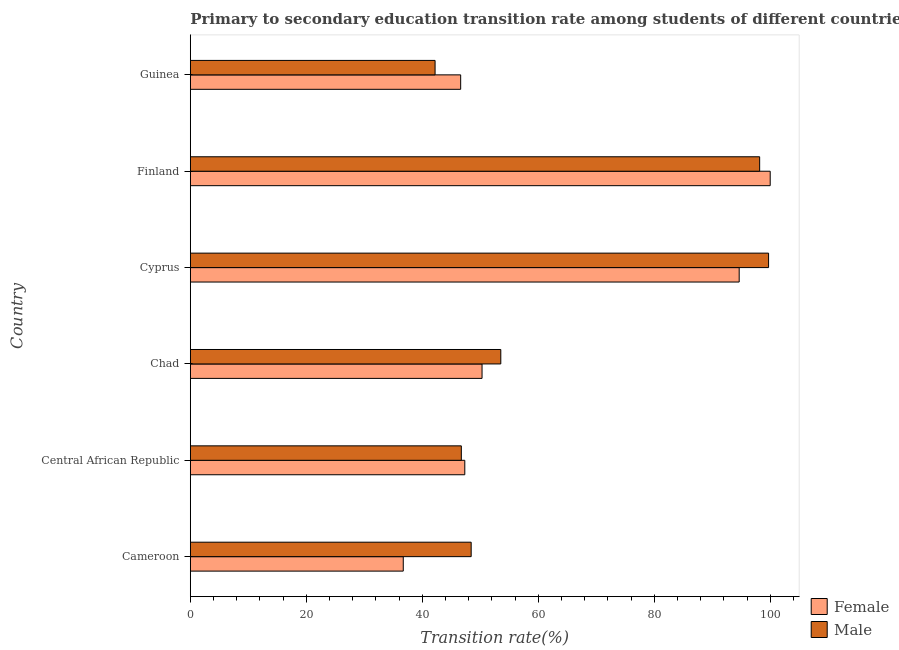Are the number of bars on each tick of the Y-axis equal?
Give a very brief answer. Yes. How many bars are there on the 4th tick from the top?
Offer a terse response. 2. What is the label of the 5th group of bars from the top?
Offer a very short reply. Central African Republic. What is the transition rate among female students in Cameroon?
Make the answer very short. 36.73. Across all countries, what is the maximum transition rate among female students?
Make the answer very short. 100. Across all countries, what is the minimum transition rate among female students?
Your response must be concise. 36.73. In which country was the transition rate among male students maximum?
Offer a very short reply. Cyprus. In which country was the transition rate among male students minimum?
Offer a very short reply. Guinea. What is the total transition rate among female students in the graph?
Your response must be concise. 375.65. What is the difference between the transition rate among female students in Cyprus and that in Guinea?
Your answer should be very brief. 48.03. What is the difference between the transition rate among male students in Finland and the transition rate among female students in Cyprus?
Give a very brief answer. 3.53. What is the average transition rate among male students per country?
Your response must be concise. 64.81. What is the difference between the transition rate among male students and transition rate among female students in Finland?
Offer a terse response. -1.82. What is the ratio of the transition rate among male students in Cameroon to that in Guinea?
Make the answer very short. 1.15. Is the difference between the transition rate among male students in Central African Republic and Chad greater than the difference between the transition rate among female students in Central African Republic and Chad?
Offer a terse response. No. What is the difference between the highest and the second highest transition rate among male students?
Ensure brevity in your answer.  1.54. What is the difference between the highest and the lowest transition rate among male students?
Give a very brief answer. 57.51. In how many countries, is the transition rate among female students greater than the average transition rate among female students taken over all countries?
Your answer should be compact. 2. What does the 1st bar from the bottom in Central African Republic represents?
Make the answer very short. Female. Are all the bars in the graph horizontal?
Provide a short and direct response. Yes. What is the difference between two consecutive major ticks on the X-axis?
Offer a very short reply. 20. Are the values on the major ticks of X-axis written in scientific E-notation?
Your answer should be compact. No. Does the graph contain grids?
Ensure brevity in your answer.  No. How many legend labels are there?
Offer a very short reply. 2. How are the legend labels stacked?
Provide a succinct answer. Vertical. What is the title of the graph?
Provide a succinct answer. Primary to secondary education transition rate among students of different countries. What is the label or title of the X-axis?
Provide a succinct answer. Transition rate(%). What is the Transition rate(%) in Female in Cameroon?
Offer a terse response. 36.73. What is the Transition rate(%) in Male in Cameroon?
Make the answer very short. 48.44. What is the Transition rate(%) of Female in Central African Republic?
Provide a succinct answer. 47.34. What is the Transition rate(%) of Male in Central African Republic?
Provide a short and direct response. 46.74. What is the Transition rate(%) in Female in Chad?
Provide a succinct answer. 50.31. What is the Transition rate(%) of Male in Chad?
Offer a terse response. 53.54. What is the Transition rate(%) of Female in Cyprus?
Your answer should be compact. 94.65. What is the Transition rate(%) in Male in Cyprus?
Provide a succinct answer. 99.72. What is the Transition rate(%) of Male in Finland?
Provide a succinct answer. 98.18. What is the Transition rate(%) of Female in Guinea?
Offer a very short reply. 46.62. What is the Transition rate(%) of Male in Guinea?
Your answer should be compact. 42.21. Across all countries, what is the maximum Transition rate(%) of Female?
Your response must be concise. 100. Across all countries, what is the maximum Transition rate(%) in Male?
Your answer should be compact. 99.72. Across all countries, what is the minimum Transition rate(%) of Female?
Offer a terse response. 36.73. Across all countries, what is the minimum Transition rate(%) in Male?
Keep it short and to the point. 42.21. What is the total Transition rate(%) of Female in the graph?
Keep it short and to the point. 375.65. What is the total Transition rate(%) in Male in the graph?
Provide a succinct answer. 388.83. What is the difference between the Transition rate(%) of Female in Cameroon and that in Central African Republic?
Your response must be concise. -10.61. What is the difference between the Transition rate(%) of Male in Cameroon and that in Central African Republic?
Offer a very short reply. 1.7. What is the difference between the Transition rate(%) of Female in Cameroon and that in Chad?
Make the answer very short. -13.58. What is the difference between the Transition rate(%) in Male in Cameroon and that in Chad?
Offer a very short reply. -5.11. What is the difference between the Transition rate(%) in Female in Cameroon and that in Cyprus?
Provide a short and direct response. -57.93. What is the difference between the Transition rate(%) in Male in Cameroon and that in Cyprus?
Provide a succinct answer. -51.29. What is the difference between the Transition rate(%) in Female in Cameroon and that in Finland?
Your answer should be very brief. -63.27. What is the difference between the Transition rate(%) of Male in Cameroon and that in Finland?
Keep it short and to the point. -49.75. What is the difference between the Transition rate(%) in Female in Cameroon and that in Guinea?
Provide a short and direct response. -9.9. What is the difference between the Transition rate(%) of Male in Cameroon and that in Guinea?
Make the answer very short. 6.22. What is the difference between the Transition rate(%) of Female in Central African Republic and that in Chad?
Keep it short and to the point. -2.97. What is the difference between the Transition rate(%) of Male in Central African Republic and that in Chad?
Your answer should be compact. -6.81. What is the difference between the Transition rate(%) in Female in Central African Republic and that in Cyprus?
Give a very brief answer. -47.32. What is the difference between the Transition rate(%) in Male in Central African Republic and that in Cyprus?
Make the answer very short. -52.98. What is the difference between the Transition rate(%) of Female in Central African Republic and that in Finland?
Provide a short and direct response. -52.66. What is the difference between the Transition rate(%) in Male in Central African Republic and that in Finland?
Keep it short and to the point. -51.44. What is the difference between the Transition rate(%) in Female in Central African Republic and that in Guinea?
Offer a terse response. 0.71. What is the difference between the Transition rate(%) in Male in Central African Republic and that in Guinea?
Provide a short and direct response. 4.53. What is the difference between the Transition rate(%) of Female in Chad and that in Cyprus?
Provide a succinct answer. -44.34. What is the difference between the Transition rate(%) of Male in Chad and that in Cyprus?
Offer a terse response. -46.18. What is the difference between the Transition rate(%) of Female in Chad and that in Finland?
Your answer should be compact. -49.69. What is the difference between the Transition rate(%) of Male in Chad and that in Finland?
Ensure brevity in your answer.  -44.64. What is the difference between the Transition rate(%) of Female in Chad and that in Guinea?
Your answer should be compact. 3.69. What is the difference between the Transition rate(%) in Male in Chad and that in Guinea?
Offer a terse response. 11.33. What is the difference between the Transition rate(%) in Female in Cyprus and that in Finland?
Make the answer very short. -5.35. What is the difference between the Transition rate(%) of Male in Cyprus and that in Finland?
Give a very brief answer. 1.54. What is the difference between the Transition rate(%) of Female in Cyprus and that in Guinea?
Provide a succinct answer. 48.03. What is the difference between the Transition rate(%) in Male in Cyprus and that in Guinea?
Provide a short and direct response. 57.51. What is the difference between the Transition rate(%) in Female in Finland and that in Guinea?
Offer a very short reply. 53.38. What is the difference between the Transition rate(%) in Male in Finland and that in Guinea?
Offer a terse response. 55.97. What is the difference between the Transition rate(%) in Female in Cameroon and the Transition rate(%) in Male in Central African Republic?
Provide a short and direct response. -10.01. What is the difference between the Transition rate(%) in Female in Cameroon and the Transition rate(%) in Male in Chad?
Your response must be concise. -16.82. What is the difference between the Transition rate(%) in Female in Cameroon and the Transition rate(%) in Male in Cyprus?
Give a very brief answer. -63. What is the difference between the Transition rate(%) of Female in Cameroon and the Transition rate(%) of Male in Finland?
Your answer should be compact. -61.46. What is the difference between the Transition rate(%) in Female in Cameroon and the Transition rate(%) in Male in Guinea?
Keep it short and to the point. -5.49. What is the difference between the Transition rate(%) in Female in Central African Republic and the Transition rate(%) in Male in Chad?
Offer a terse response. -6.21. What is the difference between the Transition rate(%) of Female in Central African Republic and the Transition rate(%) of Male in Cyprus?
Your answer should be very brief. -52.39. What is the difference between the Transition rate(%) in Female in Central African Republic and the Transition rate(%) in Male in Finland?
Provide a succinct answer. -50.85. What is the difference between the Transition rate(%) in Female in Central African Republic and the Transition rate(%) in Male in Guinea?
Your answer should be compact. 5.12. What is the difference between the Transition rate(%) in Female in Chad and the Transition rate(%) in Male in Cyprus?
Make the answer very short. -49.41. What is the difference between the Transition rate(%) of Female in Chad and the Transition rate(%) of Male in Finland?
Keep it short and to the point. -47.87. What is the difference between the Transition rate(%) in Female in Chad and the Transition rate(%) in Male in Guinea?
Provide a short and direct response. 8.1. What is the difference between the Transition rate(%) of Female in Cyprus and the Transition rate(%) of Male in Finland?
Your answer should be compact. -3.53. What is the difference between the Transition rate(%) in Female in Cyprus and the Transition rate(%) in Male in Guinea?
Offer a terse response. 52.44. What is the difference between the Transition rate(%) of Female in Finland and the Transition rate(%) of Male in Guinea?
Keep it short and to the point. 57.79. What is the average Transition rate(%) of Female per country?
Your answer should be very brief. 62.61. What is the average Transition rate(%) in Male per country?
Your answer should be very brief. 64.81. What is the difference between the Transition rate(%) of Female and Transition rate(%) of Male in Cameroon?
Your answer should be compact. -11.71. What is the difference between the Transition rate(%) in Female and Transition rate(%) in Male in Central African Republic?
Keep it short and to the point. 0.6. What is the difference between the Transition rate(%) in Female and Transition rate(%) in Male in Chad?
Provide a short and direct response. -3.23. What is the difference between the Transition rate(%) in Female and Transition rate(%) in Male in Cyprus?
Offer a very short reply. -5.07. What is the difference between the Transition rate(%) of Female and Transition rate(%) of Male in Finland?
Offer a terse response. 1.82. What is the difference between the Transition rate(%) in Female and Transition rate(%) in Male in Guinea?
Your answer should be compact. 4.41. What is the ratio of the Transition rate(%) in Female in Cameroon to that in Central African Republic?
Keep it short and to the point. 0.78. What is the ratio of the Transition rate(%) of Male in Cameroon to that in Central African Republic?
Offer a terse response. 1.04. What is the ratio of the Transition rate(%) of Female in Cameroon to that in Chad?
Offer a very short reply. 0.73. What is the ratio of the Transition rate(%) of Male in Cameroon to that in Chad?
Keep it short and to the point. 0.9. What is the ratio of the Transition rate(%) in Female in Cameroon to that in Cyprus?
Your answer should be very brief. 0.39. What is the ratio of the Transition rate(%) of Male in Cameroon to that in Cyprus?
Your response must be concise. 0.49. What is the ratio of the Transition rate(%) of Female in Cameroon to that in Finland?
Ensure brevity in your answer.  0.37. What is the ratio of the Transition rate(%) in Male in Cameroon to that in Finland?
Your answer should be compact. 0.49. What is the ratio of the Transition rate(%) in Female in Cameroon to that in Guinea?
Offer a terse response. 0.79. What is the ratio of the Transition rate(%) of Male in Cameroon to that in Guinea?
Your answer should be very brief. 1.15. What is the ratio of the Transition rate(%) of Female in Central African Republic to that in Chad?
Keep it short and to the point. 0.94. What is the ratio of the Transition rate(%) in Male in Central African Republic to that in Chad?
Ensure brevity in your answer.  0.87. What is the ratio of the Transition rate(%) of Female in Central African Republic to that in Cyprus?
Offer a very short reply. 0.5. What is the ratio of the Transition rate(%) of Male in Central African Republic to that in Cyprus?
Provide a short and direct response. 0.47. What is the ratio of the Transition rate(%) of Female in Central African Republic to that in Finland?
Keep it short and to the point. 0.47. What is the ratio of the Transition rate(%) of Male in Central African Republic to that in Finland?
Your response must be concise. 0.48. What is the ratio of the Transition rate(%) in Female in Central African Republic to that in Guinea?
Offer a very short reply. 1.02. What is the ratio of the Transition rate(%) of Male in Central African Republic to that in Guinea?
Your answer should be compact. 1.11. What is the ratio of the Transition rate(%) of Female in Chad to that in Cyprus?
Keep it short and to the point. 0.53. What is the ratio of the Transition rate(%) in Male in Chad to that in Cyprus?
Provide a succinct answer. 0.54. What is the ratio of the Transition rate(%) in Female in Chad to that in Finland?
Ensure brevity in your answer.  0.5. What is the ratio of the Transition rate(%) in Male in Chad to that in Finland?
Offer a terse response. 0.55. What is the ratio of the Transition rate(%) in Female in Chad to that in Guinea?
Your answer should be very brief. 1.08. What is the ratio of the Transition rate(%) of Male in Chad to that in Guinea?
Your answer should be very brief. 1.27. What is the ratio of the Transition rate(%) of Female in Cyprus to that in Finland?
Your response must be concise. 0.95. What is the ratio of the Transition rate(%) of Male in Cyprus to that in Finland?
Offer a terse response. 1.02. What is the ratio of the Transition rate(%) in Female in Cyprus to that in Guinea?
Your answer should be very brief. 2.03. What is the ratio of the Transition rate(%) in Male in Cyprus to that in Guinea?
Give a very brief answer. 2.36. What is the ratio of the Transition rate(%) of Female in Finland to that in Guinea?
Your response must be concise. 2.14. What is the ratio of the Transition rate(%) of Male in Finland to that in Guinea?
Keep it short and to the point. 2.33. What is the difference between the highest and the second highest Transition rate(%) of Female?
Your answer should be very brief. 5.35. What is the difference between the highest and the second highest Transition rate(%) of Male?
Offer a very short reply. 1.54. What is the difference between the highest and the lowest Transition rate(%) of Female?
Offer a very short reply. 63.27. What is the difference between the highest and the lowest Transition rate(%) of Male?
Your answer should be compact. 57.51. 